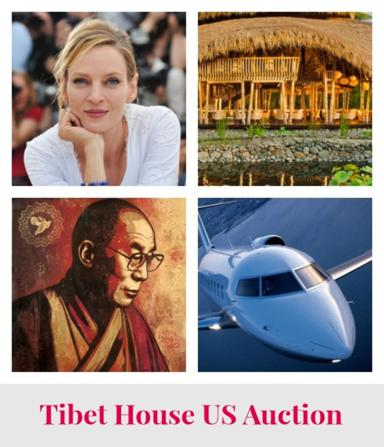Can you explain the significance of including a portrait in the collage for the auction? The portrait in the collage possibly highlights a notable figure or a patron of the Tibet House US Auction, emphasizing the personal connection and influence of individuals in supporting cultural preservation and awareness initiatives. 